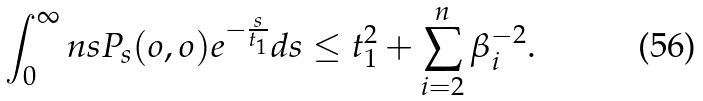Convert formula to latex. <formula><loc_0><loc_0><loc_500><loc_500>\int _ { 0 } ^ { \infty } n s P _ { s } ( o , o ) e ^ { - \frac { s } { t _ { 1 } } } d s \leq t _ { 1 } ^ { 2 } + \sum _ { i = 2 } ^ { n } \beta _ { i } ^ { - 2 } .</formula> 